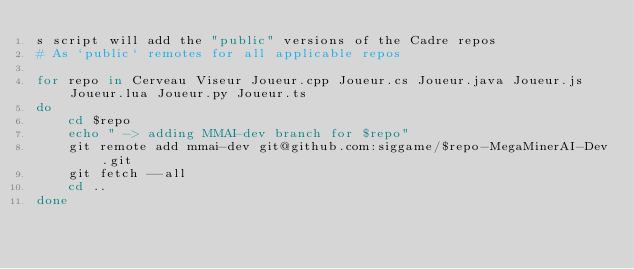<code> <loc_0><loc_0><loc_500><loc_500><_Bash_>s script will add the "public" versions of the Cadre repos
# As `public` remotes for all applicable repos

for repo in Cerveau Viseur Joueur.cpp Joueur.cs Joueur.java Joueur.js Joueur.lua Joueur.py Joueur.ts
do
    cd $repo
    echo " -> adding MMAI-dev branch for $repo"
    git remote add mmai-dev git@github.com:siggame/$repo-MegaMinerAI-Dev.git
    git fetch --all
    cd ..
done

</code> 